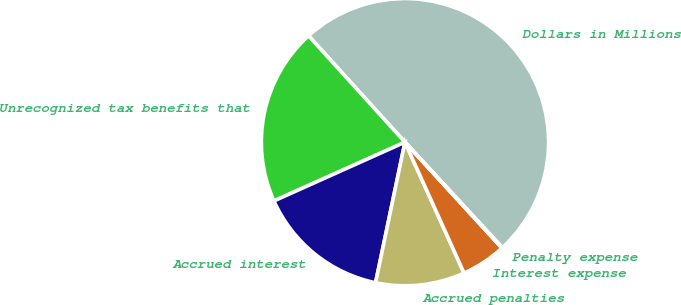<chart> <loc_0><loc_0><loc_500><loc_500><pie_chart><fcel>Dollars in Millions<fcel>Unrecognized tax benefits that<fcel>Accrued interest<fcel>Accrued penalties<fcel>Interest expense<fcel>Penalty expense<nl><fcel>49.85%<fcel>19.99%<fcel>15.01%<fcel>10.03%<fcel>5.05%<fcel>0.07%<nl></chart> 